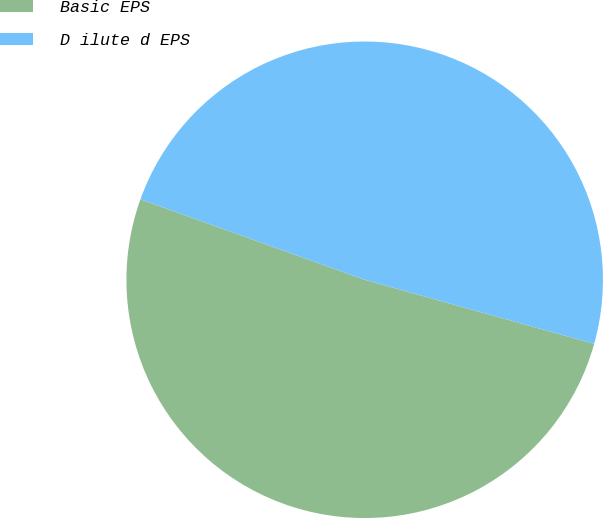Convert chart to OTSL. <chart><loc_0><loc_0><loc_500><loc_500><pie_chart><fcel>Basic EPS<fcel>D ilute d EPS<nl><fcel>51.15%<fcel>48.85%<nl></chart> 